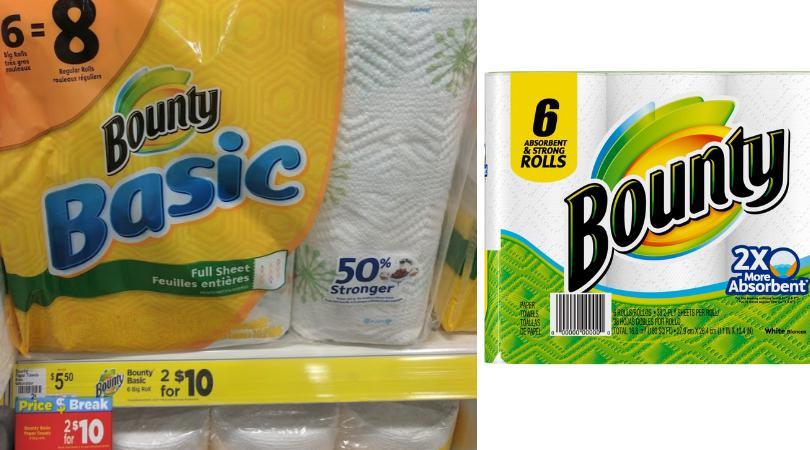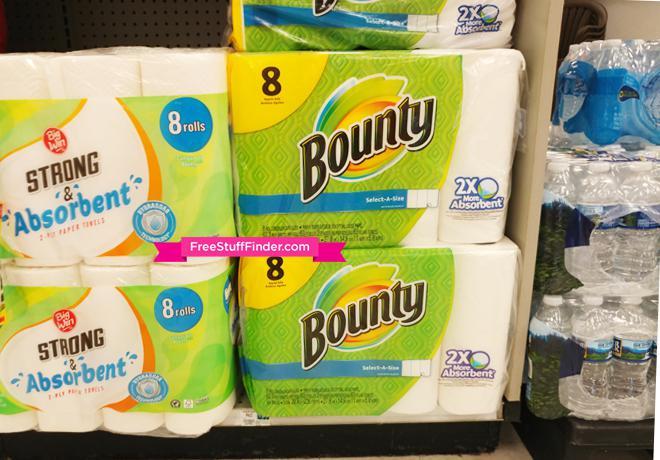The first image is the image on the left, the second image is the image on the right. Evaluate the accuracy of this statement regarding the images: "Each image shows multipack paper towels in green and yellow packaging on store shelves with white pegboard.". Is it true? Answer yes or no. No. The first image is the image on the left, the second image is the image on the right. Assess this claim about the two images: "There are both Bounty and Scott brand paper towels.". Correct or not? Answer yes or no. No. 